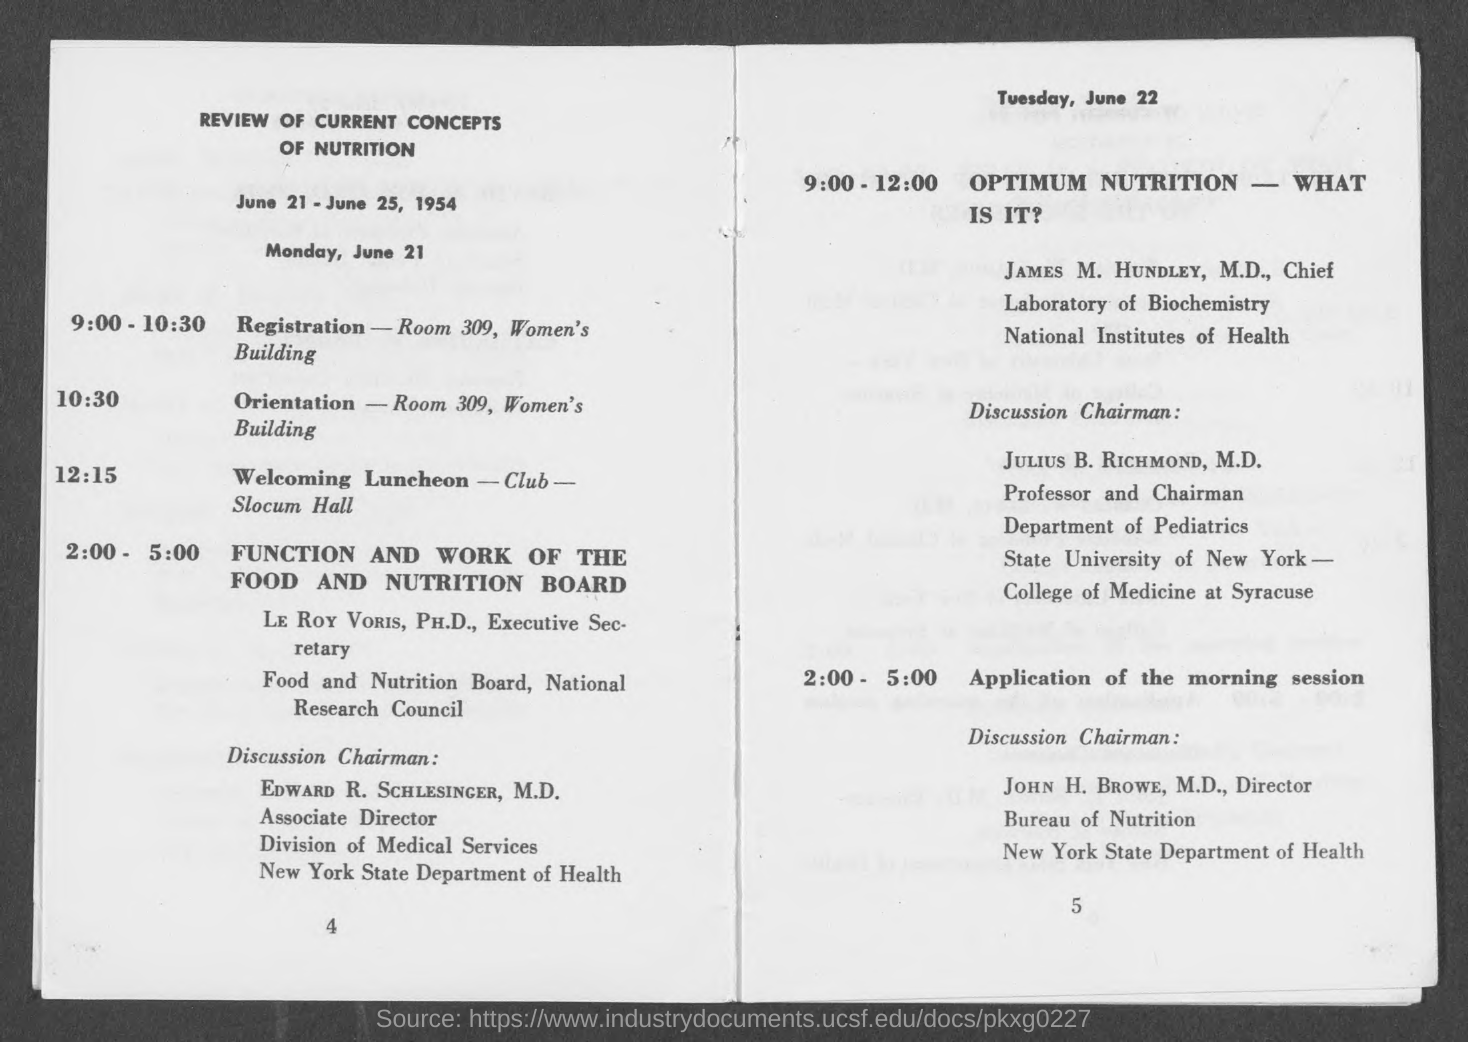What is the Title of the document?
Your response must be concise. Review of current concepts of nutrition. Where is the Registration?
Your response must be concise. Room 309, Women's Building. Where is the Orientation?
Give a very brief answer. Room 309, Women's Building. 